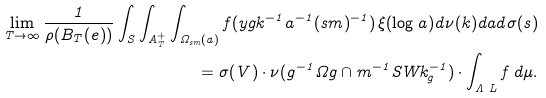Convert formula to latex. <formula><loc_0><loc_0><loc_500><loc_500>\lim _ { T \to \infty } \frac { 1 } { \rho ( B _ { T } ( e ) ) } \int _ { S } \int _ { A ^ { + } _ { T } } \int _ { \Omega _ { s m } ( { a } ) } f ( y g { k } ^ { - 1 } { a } ^ { - 1 } ( s m ) ^ { - 1 } ) \, \xi ( \log { a } ) d \nu ( { k } ) d { a } d \sigma ( s ) \\ = \sigma ( V ) \cdot \nu ( { g ^ { - 1 } \Omega g \cap m ^ { - 1 } S W k _ { g } ^ { - 1 } } ) \cdot \int _ { \Lambda \ L } f \, d \mu .</formula> 